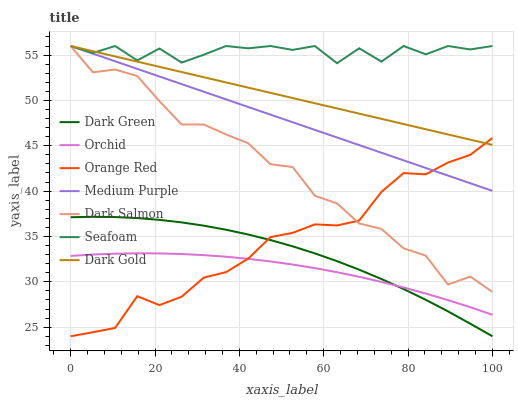Does Orchid have the minimum area under the curve?
Answer yes or no. Yes. Does Seafoam have the maximum area under the curve?
Answer yes or no. Yes. Does Dark Salmon have the minimum area under the curve?
Answer yes or no. No. Does Dark Salmon have the maximum area under the curve?
Answer yes or no. No. Is Medium Purple the smoothest?
Answer yes or no. Yes. Is Seafoam the roughest?
Answer yes or no. Yes. Is Dark Salmon the smoothest?
Answer yes or no. No. Is Dark Salmon the roughest?
Answer yes or no. No. Does Dark Green have the lowest value?
Answer yes or no. Yes. Does Dark Salmon have the lowest value?
Answer yes or no. No. Does Medium Purple have the highest value?
Answer yes or no. Yes. Does Dark Green have the highest value?
Answer yes or no. No. Is Orchid less than Dark Salmon?
Answer yes or no. Yes. Is Seafoam greater than Orange Red?
Answer yes or no. Yes. Does Dark Gold intersect Orange Red?
Answer yes or no. Yes. Is Dark Gold less than Orange Red?
Answer yes or no. No. Is Dark Gold greater than Orange Red?
Answer yes or no. No. Does Orchid intersect Dark Salmon?
Answer yes or no. No. 